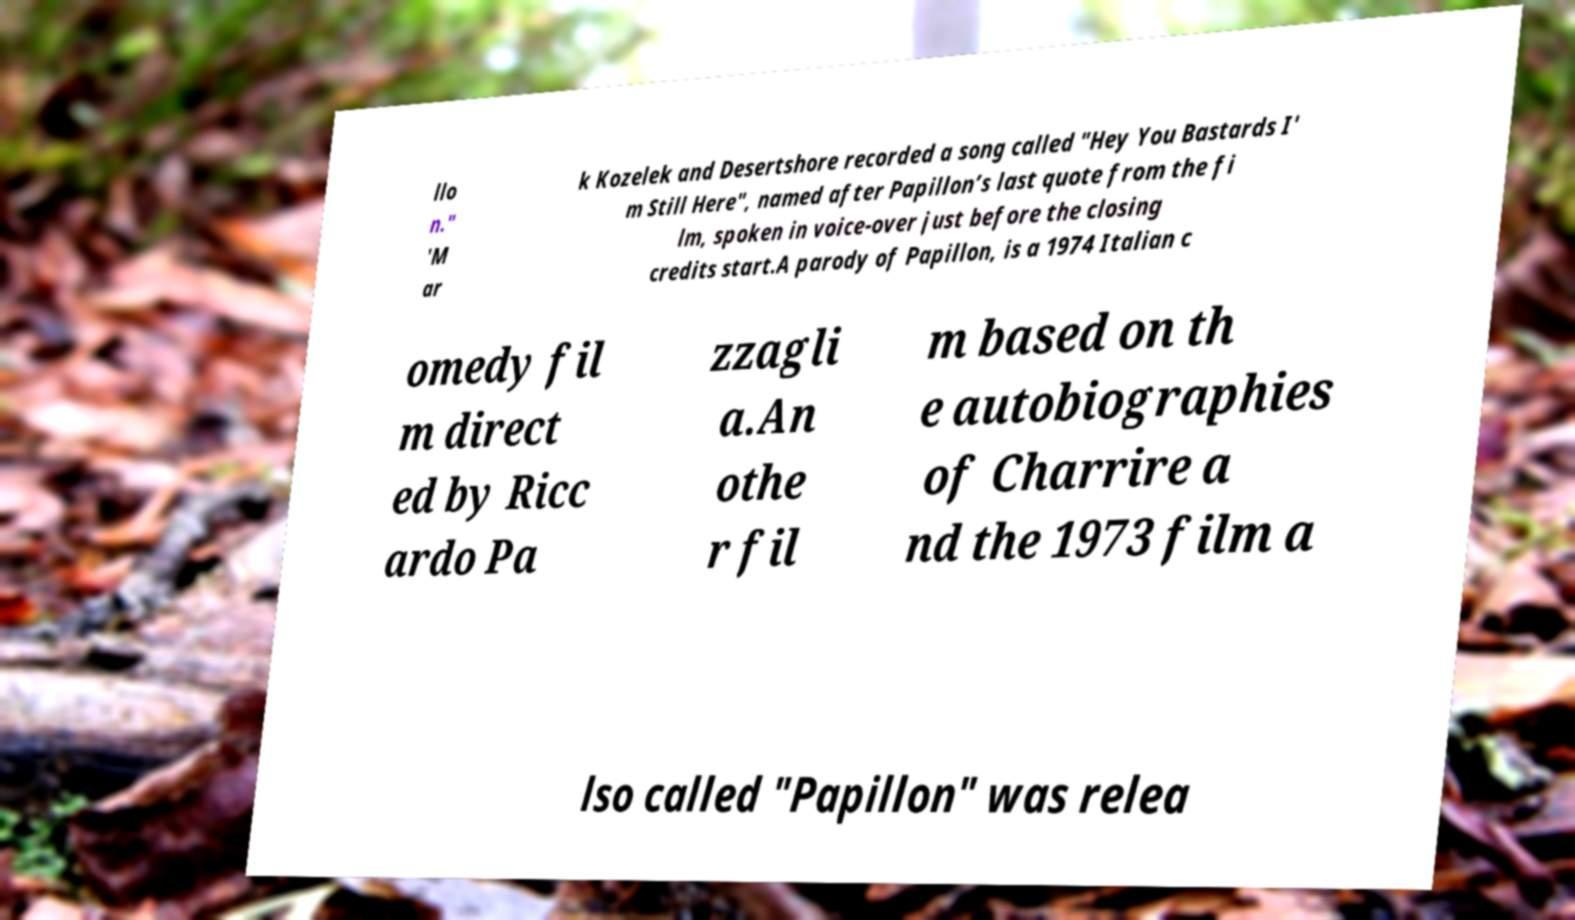Please identify and transcribe the text found in this image. llo n." 'M ar k Kozelek and Desertshore recorded a song called "Hey You Bastards I' m Still Here", named after Papillon’s last quote from the fi lm, spoken in voice-over just before the closing credits start.A parody of Papillon, is a 1974 Italian c omedy fil m direct ed by Ricc ardo Pa zzagli a.An othe r fil m based on th e autobiographies of Charrire a nd the 1973 film a lso called "Papillon" was relea 